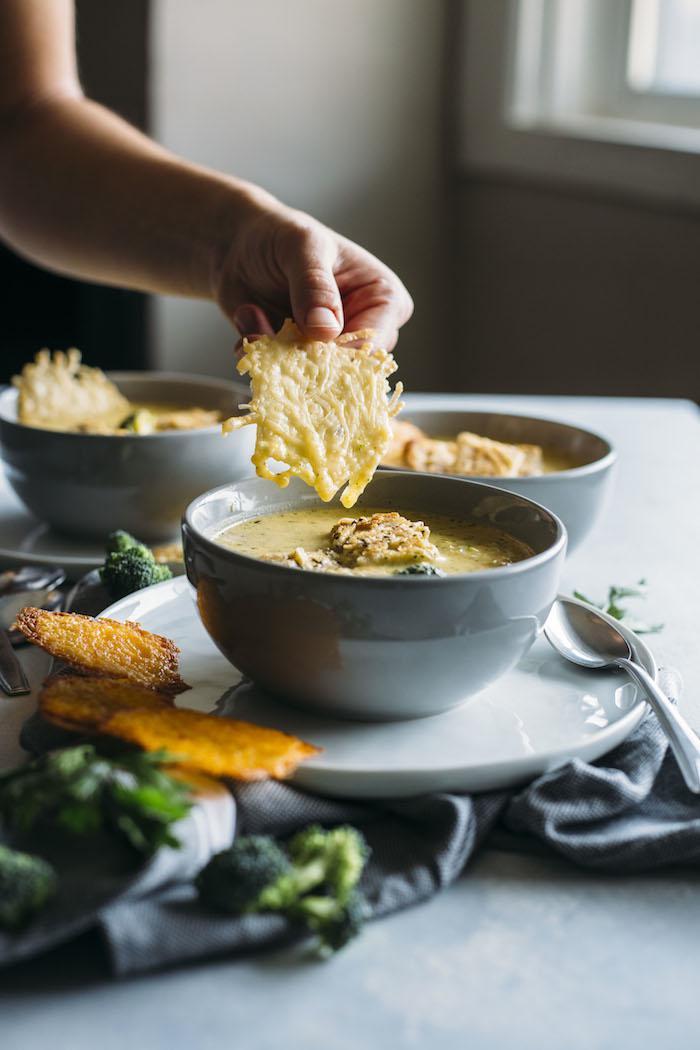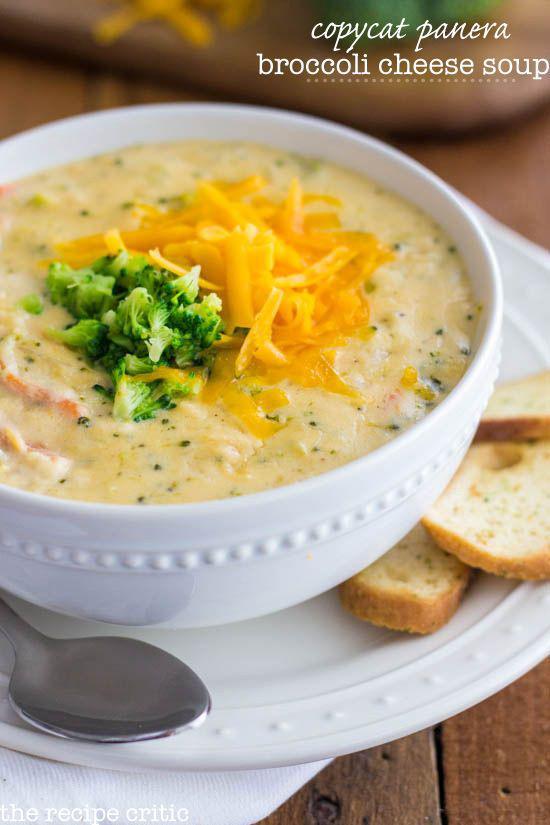The first image is the image on the left, the second image is the image on the right. Examine the images to the left and right. Is the description "A bowl of creamy soup in a white bowl with spoon is garnished with pieces of broccoli and grated cheese." accurate? Answer yes or no. Yes. The first image is the image on the left, the second image is the image on the right. Considering the images on both sides, is "An image shows a utensil inserted in a bowl of creamy soup." valid? Answer yes or no. No. 